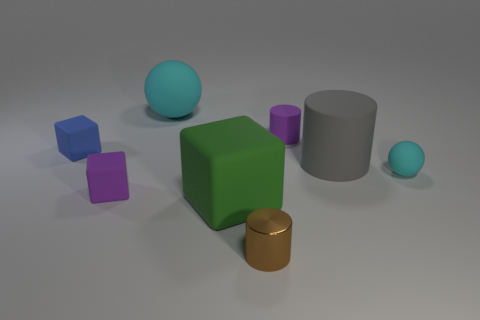Subtract all tiny matte cylinders. How many cylinders are left? 2 Subtract all brown cylinders. How many cylinders are left? 2 Add 1 tiny brown things. How many objects exist? 9 Subtract all blocks. How many objects are left? 5 Subtract 3 cubes. How many cubes are left? 0 Subtract 0 gray spheres. How many objects are left? 8 Subtract all yellow blocks. Subtract all blue cylinders. How many blocks are left? 3 Subtract all green cubes. How many green balls are left? 0 Subtract all small cyan things. Subtract all purple rubber cubes. How many objects are left? 6 Add 5 gray matte things. How many gray matte things are left? 6 